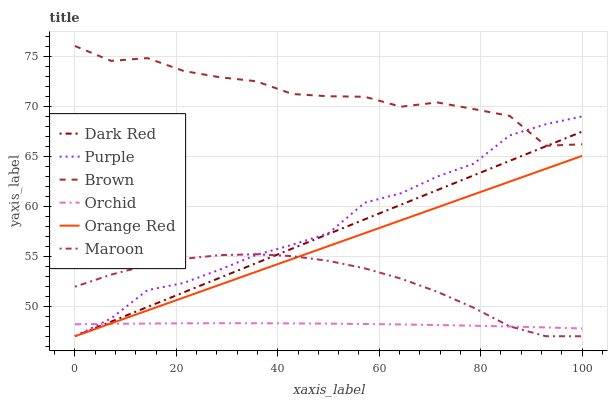Does Orchid have the minimum area under the curve?
Answer yes or no. Yes. Does Brown have the maximum area under the curve?
Answer yes or no. Yes. Does Purple have the minimum area under the curve?
Answer yes or no. No. Does Purple have the maximum area under the curve?
Answer yes or no. No. Is Orange Red the smoothest?
Answer yes or no. Yes. Is Brown the roughest?
Answer yes or no. Yes. Is Purple the smoothest?
Answer yes or no. No. Is Purple the roughest?
Answer yes or no. No. Does Purple have the lowest value?
Answer yes or no. Yes. Does Orchid have the lowest value?
Answer yes or no. No. Does Brown have the highest value?
Answer yes or no. Yes. Does Purple have the highest value?
Answer yes or no. No. Is Orchid less than Brown?
Answer yes or no. Yes. Is Brown greater than Orange Red?
Answer yes or no. Yes. Does Purple intersect Maroon?
Answer yes or no. Yes. Is Purple less than Maroon?
Answer yes or no. No. Is Purple greater than Maroon?
Answer yes or no. No. Does Orchid intersect Brown?
Answer yes or no. No. 